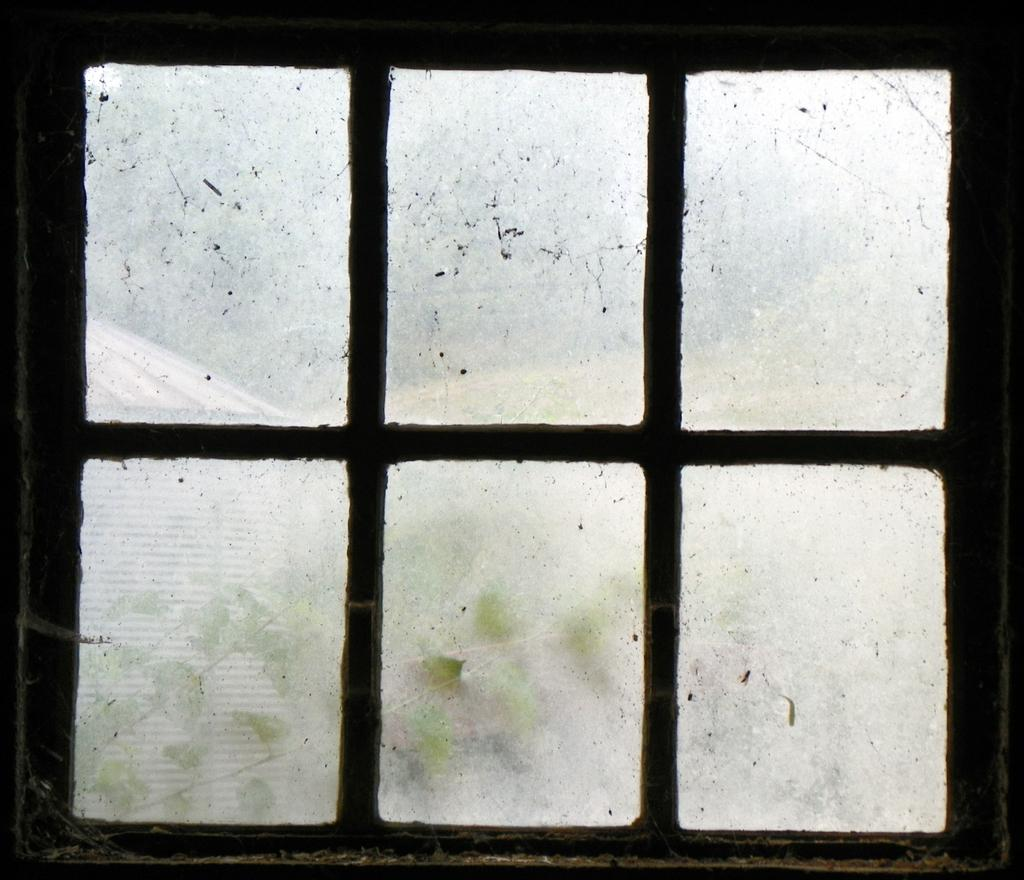What is located at the front of the image? There is a window in the front of the image. What rule does the father enforce in the image? There is no father present in the image, and therefore no rules can be enforced. What type of ornament is hanging from the window in the image? There is no ornament hanging from the window in the image. 